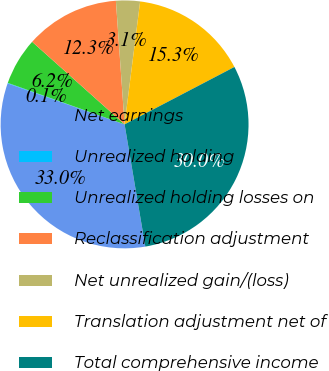Convert chart to OTSL. <chart><loc_0><loc_0><loc_500><loc_500><pie_chart><fcel>Net earnings<fcel>Unrealized holding<fcel>Unrealized holding losses on<fcel>Reclassification adjustment<fcel>Net unrealized gain/(loss)<fcel>Translation adjustment net of<fcel>Total comprehensive income<nl><fcel>33.04%<fcel>0.07%<fcel>6.17%<fcel>12.28%<fcel>3.12%<fcel>15.33%<fcel>29.99%<nl></chart> 